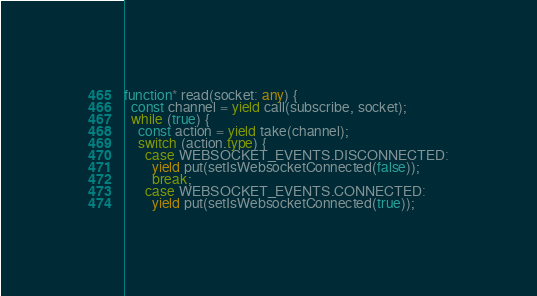<code> <loc_0><loc_0><loc_500><loc_500><_TypeScript_>function* read(socket: any) {
  const channel = yield call(subscribe, socket);
  while (true) {
    const action = yield take(channel);
    switch (action.type) {
      case WEBSOCKET_EVENTS.DISCONNECTED:
        yield put(setIsWebsocketConnected(false));
        break;
      case WEBSOCKET_EVENTS.CONNECTED:
        yield put(setIsWebsocketConnected(true));</code> 